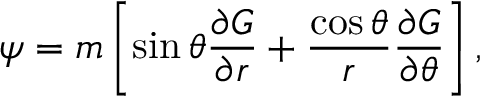Convert formula to latex. <formula><loc_0><loc_0><loc_500><loc_500>\psi = m \left [ \sin \theta \frac { \partial G } { \partial r } + \frac { \cos \theta } { r } \frac { \partial G } { \partial \theta } \right ] ,</formula> 